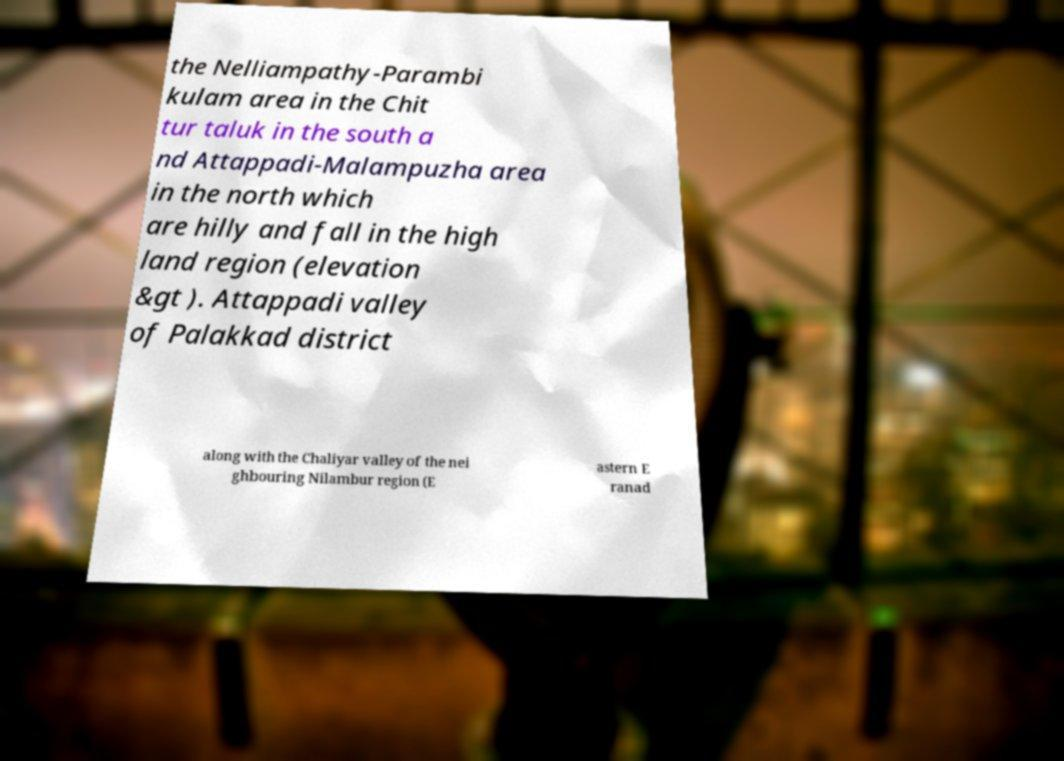Please identify and transcribe the text found in this image. the Nelliampathy-Parambi kulam area in the Chit tur taluk in the south a nd Attappadi-Malampuzha area in the north which are hilly and fall in the high land region (elevation &gt ). Attappadi valley of Palakkad district along with the Chaliyar valley of the nei ghbouring Nilambur region (E astern E ranad 